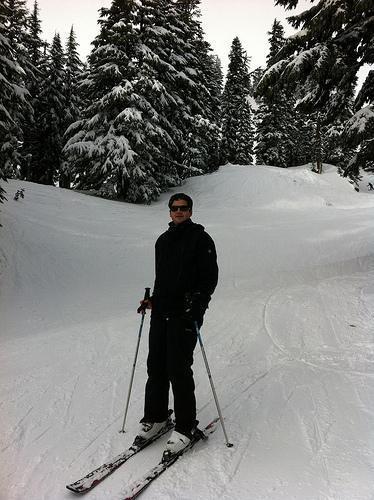How many poles is the man holding?
Give a very brief answer. 2. 